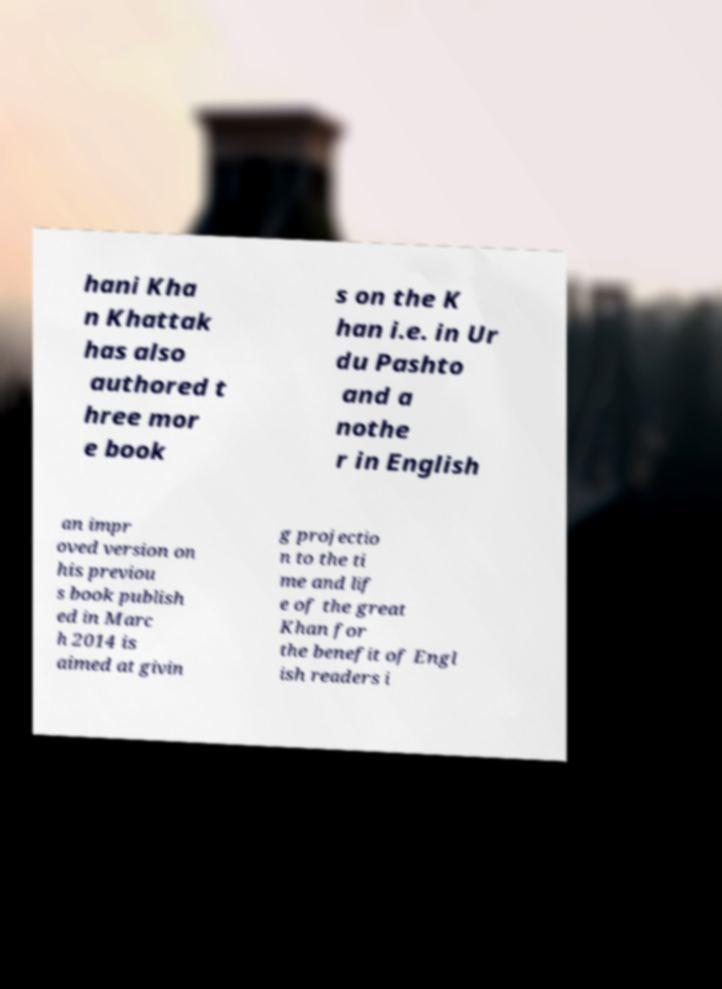Can you accurately transcribe the text from the provided image for me? hani Kha n Khattak has also authored t hree mor e book s on the K han i.e. in Ur du Pashto and a nothe r in English an impr oved version on his previou s book publish ed in Marc h 2014 is aimed at givin g projectio n to the ti me and lif e of the great Khan for the benefit of Engl ish readers i 